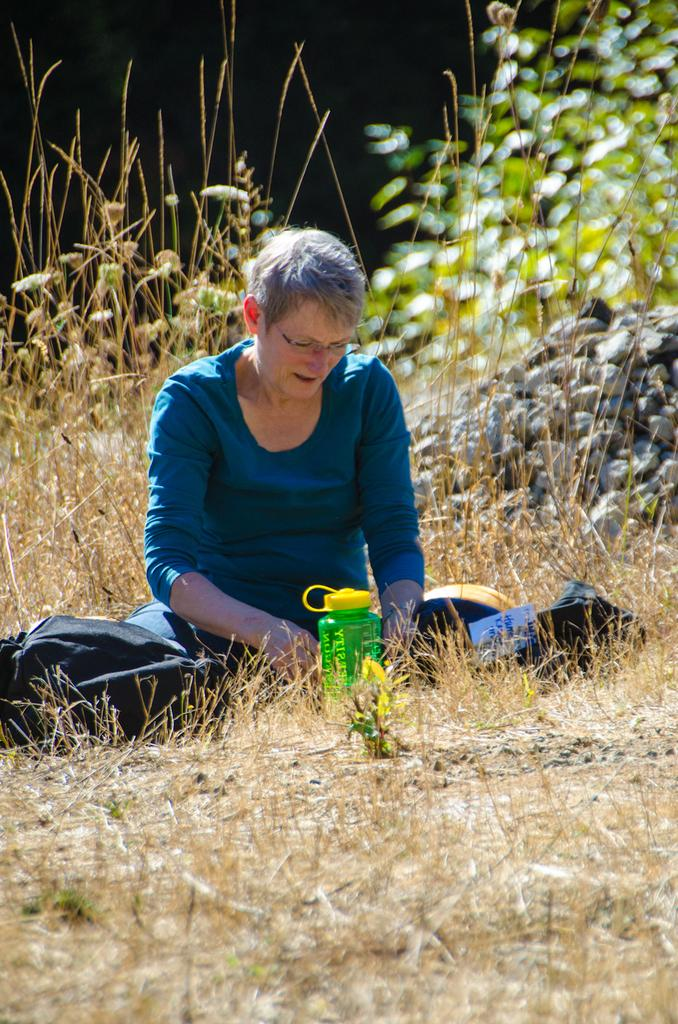What color is the t-shirt the woman is wearing in the image? The woman is wearing a blue t-shirt in the image. What accessory is the woman wearing on her face? The woman is wearing spectacles in the image. Where is the woman sitting in the image? The woman is sitting on the ground in the image. What objects can be seen on the ground near the woman? There is a bottle and a bag on the ground near the woman. What can be seen in the background of the image? There are plants and stones in the background of the image. Can you hear the woman whistling in the image? There is no indication of sound in the image, so it cannot be determined if the woman is whistling or not. 